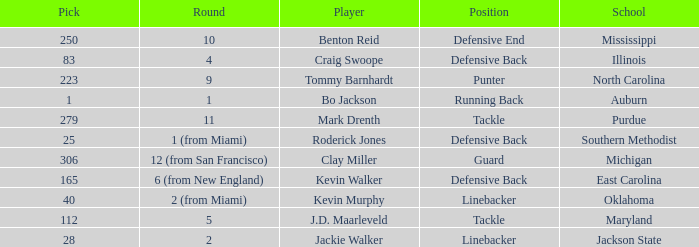What school did bo jackson attend? Auburn. Could you help me parse every detail presented in this table? {'header': ['Pick', 'Round', 'Player', 'Position', 'School'], 'rows': [['250', '10', 'Benton Reid', 'Defensive End', 'Mississippi'], ['83', '4', 'Craig Swoope', 'Defensive Back', 'Illinois'], ['223', '9', 'Tommy Barnhardt', 'Punter', 'North Carolina'], ['1', '1', 'Bo Jackson', 'Running Back', 'Auburn'], ['279', '11', 'Mark Drenth', 'Tackle', 'Purdue'], ['25', '1 (from Miami)', 'Roderick Jones', 'Defensive Back', 'Southern Methodist'], ['306', '12 (from San Francisco)', 'Clay Miller', 'Guard', 'Michigan'], ['165', '6 (from New England)', 'Kevin Walker', 'Defensive Back', 'East Carolina'], ['40', '2 (from Miami)', 'Kevin Murphy', 'Linebacker', 'Oklahoma'], ['112', '5', 'J.D. Maarleveld', 'Tackle', 'Maryland'], ['28', '2', 'Jackie Walker', 'Linebacker', 'Jackson State']]} 